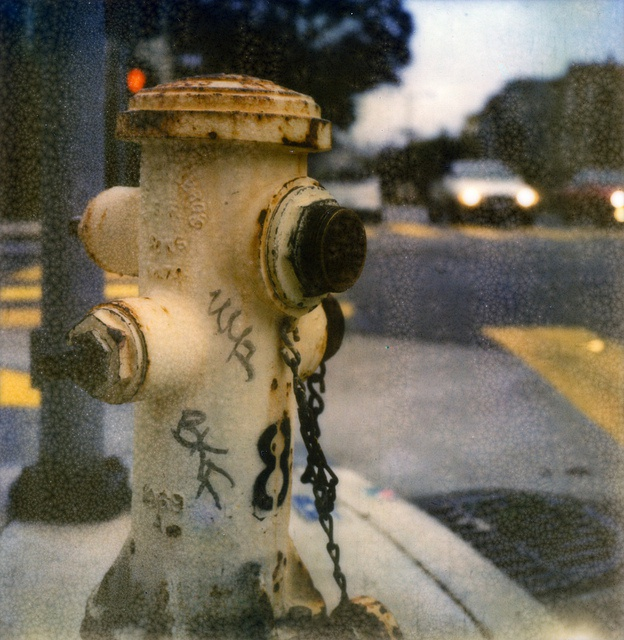Describe the objects in this image and their specific colors. I can see fire hydrant in navy, tan, olive, black, and gray tones, car in navy, black, lightgray, gray, and darkgray tones, and car in navy, gray, black, and maroon tones in this image. 